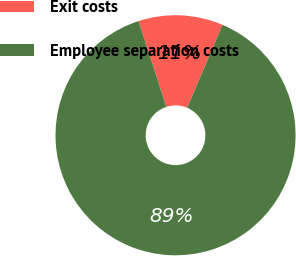Convert chart to OTSL. <chart><loc_0><loc_0><loc_500><loc_500><pie_chart><fcel>Exit costs<fcel>Employee separation costs<nl><fcel>11.39%<fcel>88.61%<nl></chart> 